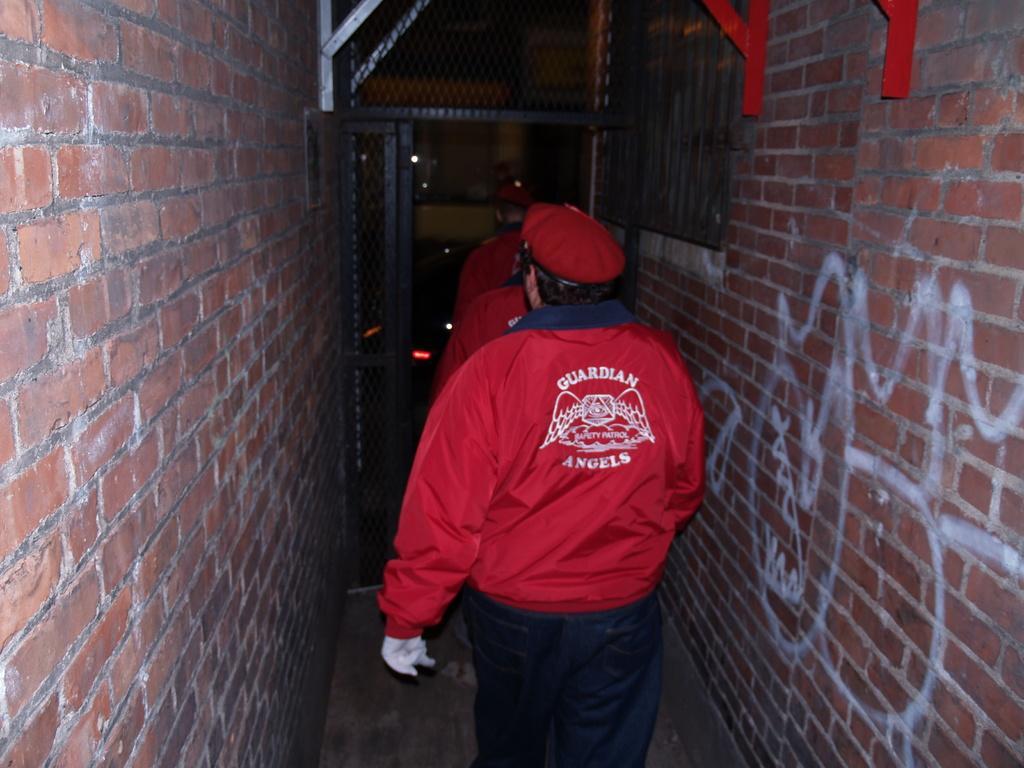In one or two sentences, can you explain what this image depicts? In the image there are a group of guards moving in between the path of two walls, the walls are constructed with bricks. 